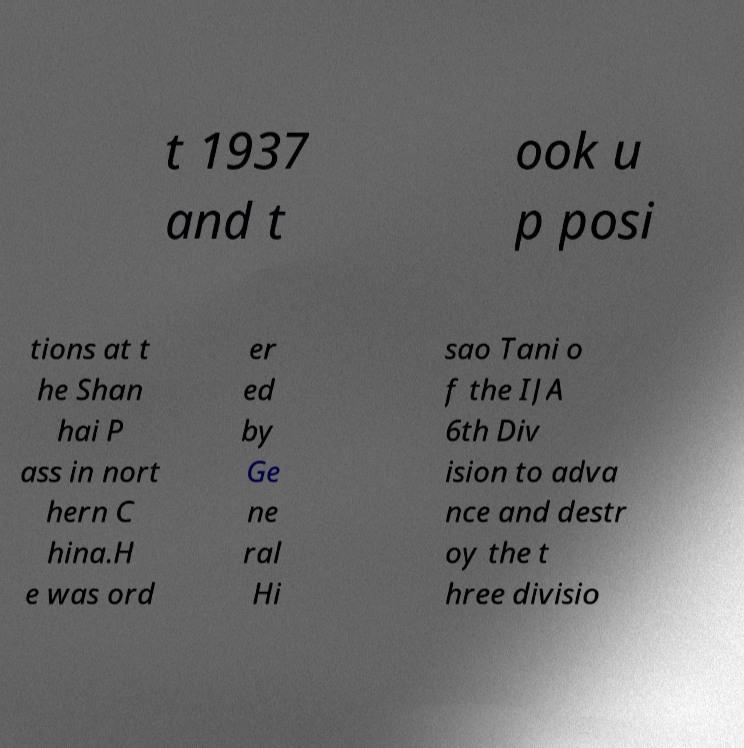Could you extract and type out the text from this image? t 1937 and t ook u p posi tions at t he Shan hai P ass in nort hern C hina.H e was ord er ed by Ge ne ral Hi sao Tani o f the IJA 6th Div ision to adva nce and destr oy the t hree divisio 